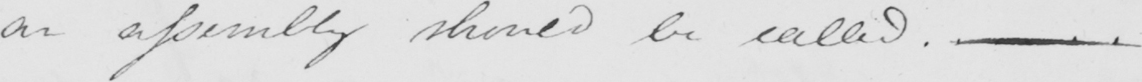What text is written in this handwritten line? an assembly should be called .  <gap/> 